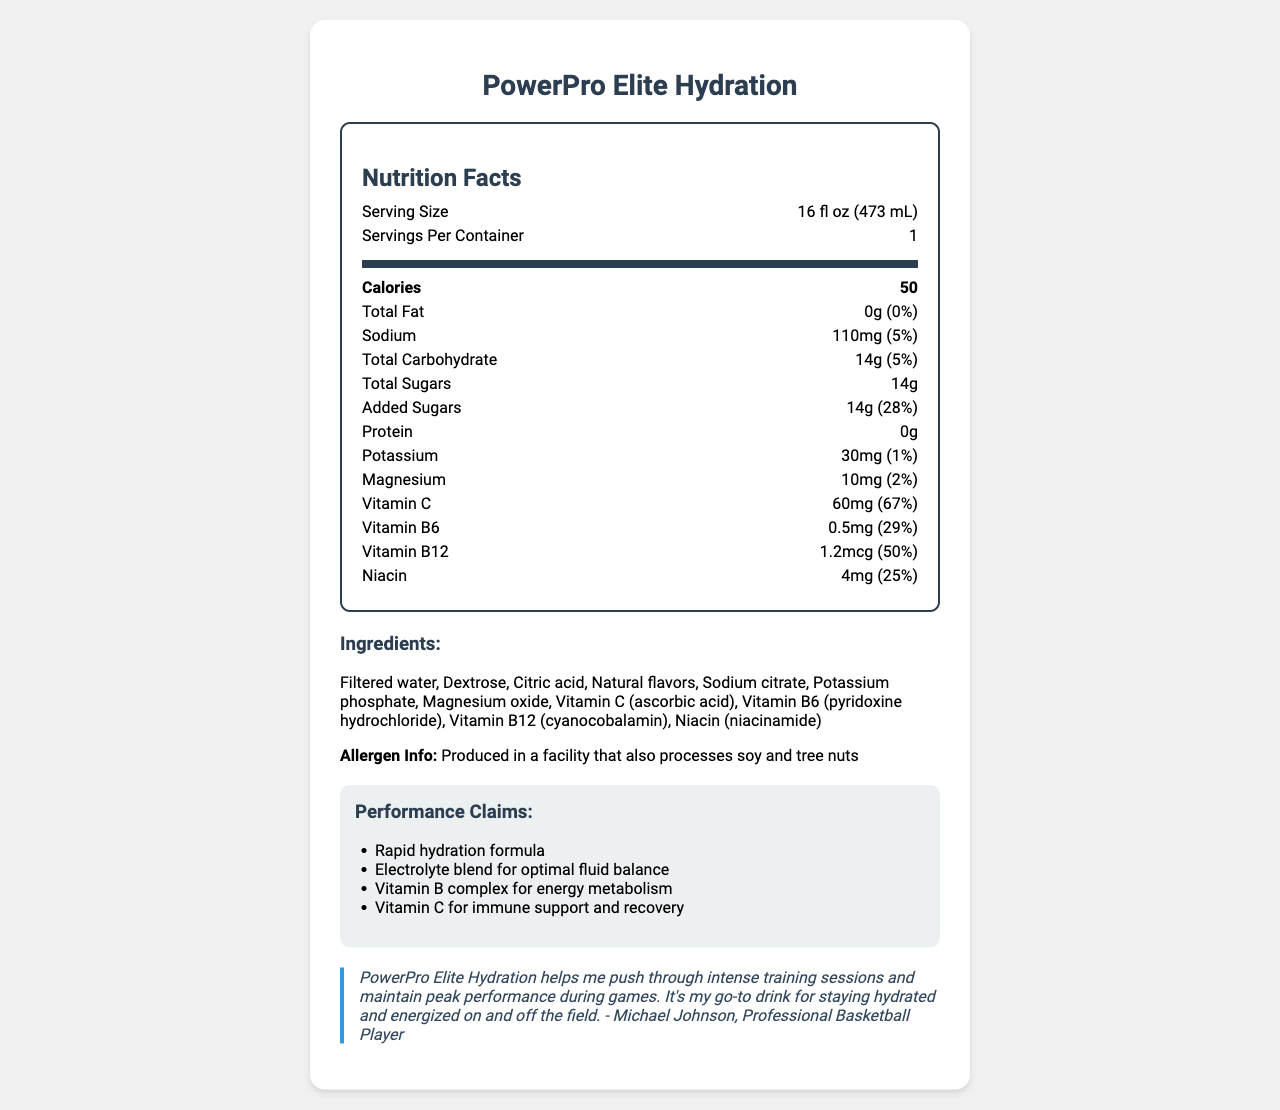what is the serving size? The serving size is mentioned at the top of the nutrition label: "Serving Size 16 fl oz (473mL)".
Answer: 16 fl oz (473 mL) how many calories are in one serving? The calories are listed in bold under the Nutrition Facts: "Calories 50".
Answer: 50 what is the total amount of sugars per serving? The total sugars are listed under the Total Carbohydrate section: "Total Sugars 14g".
Answer: 14g how much sodium does this sports drink contain per serving? The sodium content is listed under the Sodium section: "Sodium 110mg (5%)".
Answer: 110mg what vitamins are included in PowerPro Elite Hydration? The included vitamins are listed under the Nutrition Facts section: "Vitamin C, Vitamin B6, Vitamin B12, Niacin".
Answer: Vitamin C, Vitamin B6, Vitamin B12, Niacin what is the main ingredient in PowerPro Elite Hydration? The main ingredient is the first listed in the ingredients section: "Filtered water".
Answer: Filtered water which of the following is a performance claim of the drink? A. Enhances muscle growth B. Rapid hydration formula C. Improves sleep quality The performance claims listed include "Rapid hydration formula", "Electrolyte blend for optimal fluid balance", "Vitamin B complex for energy metabolism", and "Vitamin C for immune support and recovery".
Answer: B how much Vitamin C is in one serving, and what percentage of the daily value does this represent? A. 30mg, 50% B. 60mg, 67% C. 90mg, 100% Vitamin C is listed as containing 60mg, and the daily value percentage is stated as 67%.
Answer: B is this product suitable for people with soy or tree nut allergies? The allergen information states: "Produced in a facility that also processes soy and tree nuts".
Answer: No what does the athlete testimonial suggest about the product's benefits? The testimonial mentions several benefits: "PowerPro Elite Hydration helps me push through intense training sessions and maintain peak performance during games. It's my go-to drink for staying hydrated and energized on and off the field."
Answer: Helps push through intense training sessions, maintain peak performance, stay hydrated and energized summarize the main points of the document. The document presents all critical nutrition information about the sports drink, ingredient details, performance claims highlighting rapid hydration and energy support, and an athlete's testimonial confirming its efficacy.
Answer: The document provides the nutrition facts and performance claims for PowerPro Elite Hydration, a sports drink. It includes detailed information about the drink’s serving size, caloric content, fats, sodium, carbohydrates, sugars, protein, potassium, magnesium, vitamins, ingredients, and allergen information. Additionally, the drink’s performance claims emphasize rapid hydration, electrolyte balance, and energy metabolism, supported by an athlete's testimonial. what are the potential allergens in PowerPro Elite Hydration? The document states: "Produced in a facility that also processes soy and tree nuts," but it does not clarify if the product itself contains these allergens.
Answer: Cannot be Determined how much protein is in one serving? Under the Nutrition Facts, it clearly states: "Protein 0g".
Answer: 0g 